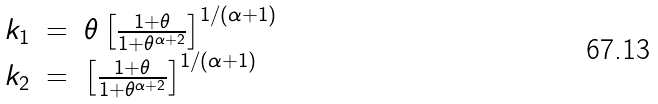<formula> <loc_0><loc_0><loc_500><loc_500>\begin{array} { l l l l l l } k _ { 1 } & = & \theta \left [ \frac { 1 + \theta } { 1 + \theta ^ { \alpha + 2 } } \right ] ^ { 1 / ( \alpha + 1 ) } \\ k _ { 2 } & = & \left [ \frac { 1 + \theta } { 1 + \theta ^ { \alpha + 2 } } \right ] ^ { 1 / ( \alpha + 1 ) } \end{array}</formula> 